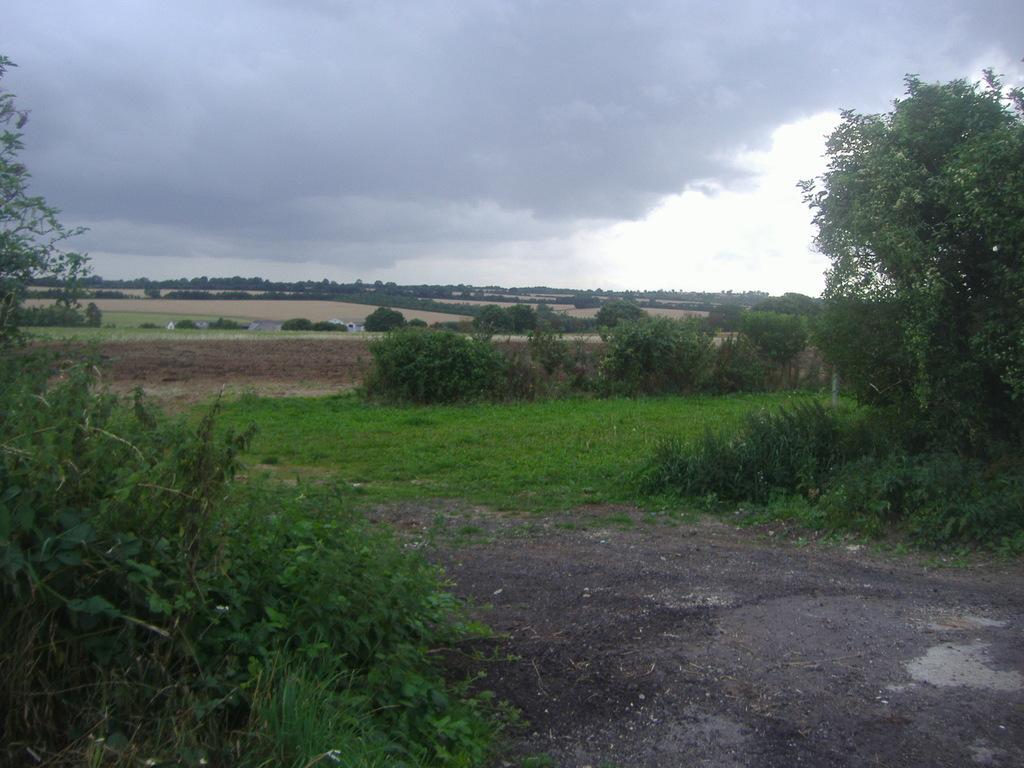How would you summarize this image in a sentence or two? At the bottom of the image, we can see land and plants. In the middle of the image, we can see glass, plants and trees. At the top of the image, we can see the sky covered with clouds. 